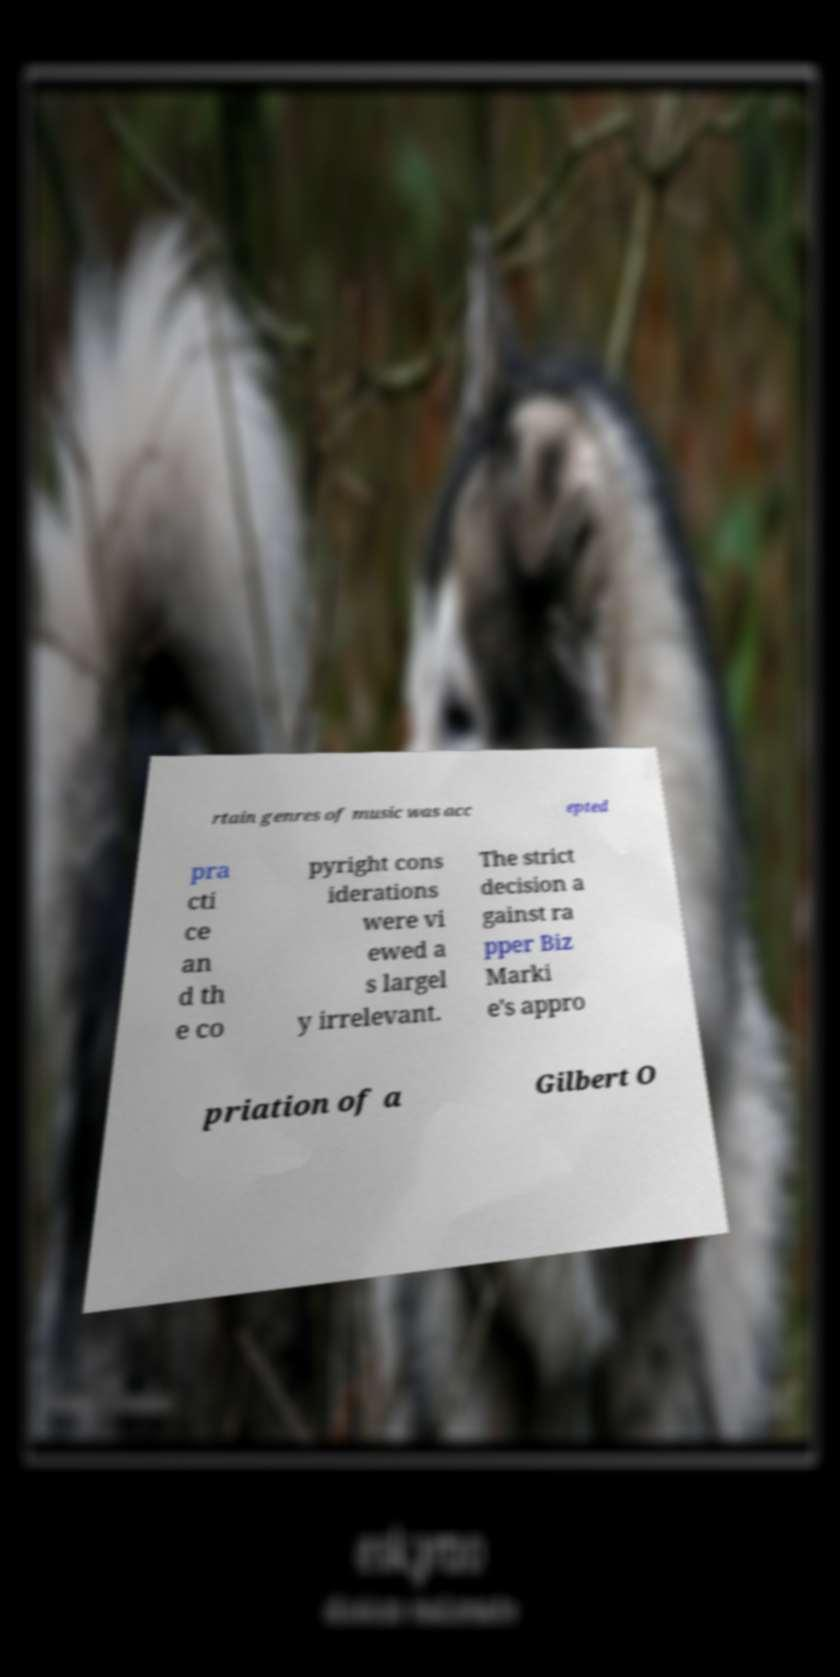What messages or text are displayed in this image? I need them in a readable, typed format. rtain genres of music was acc epted pra cti ce an d th e co pyright cons iderations were vi ewed a s largel y irrelevant. The strict decision a gainst ra pper Biz Marki e's appro priation of a Gilbert O 